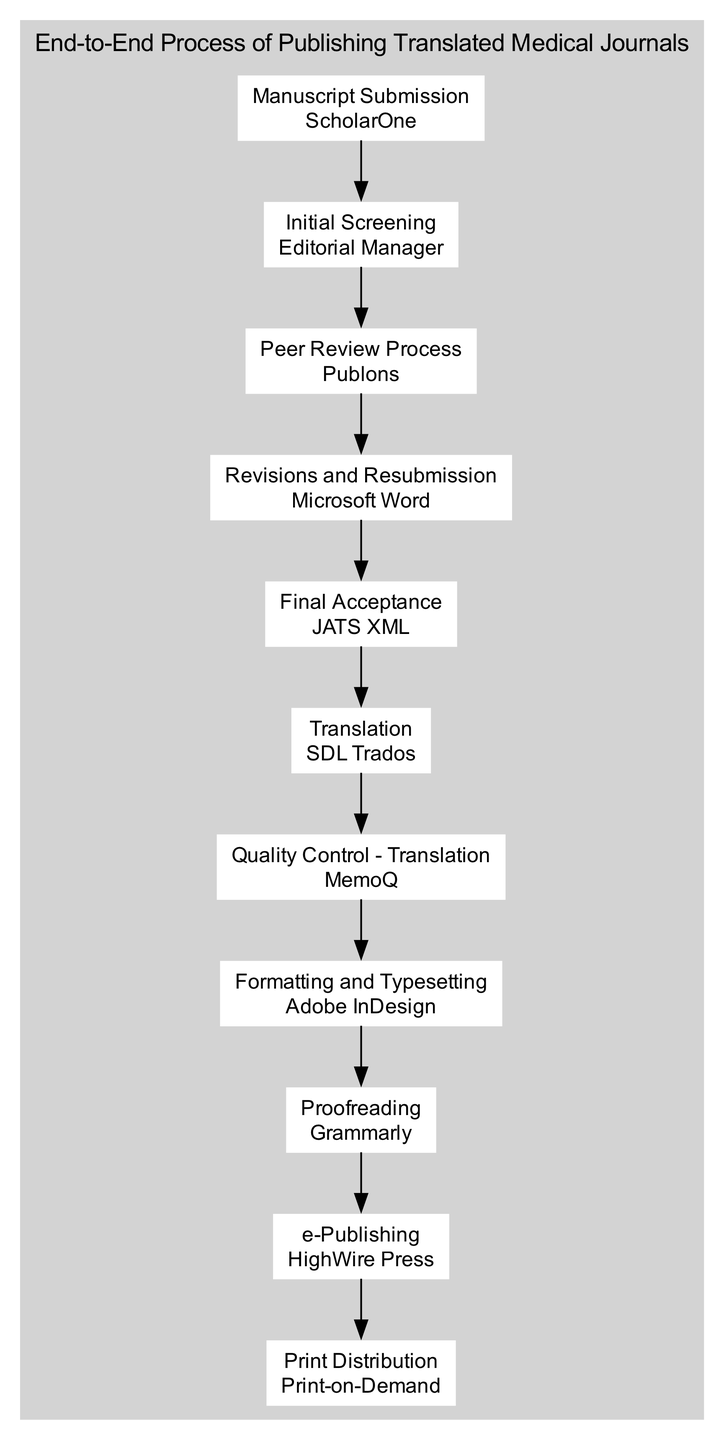What is the first step in the clinical pathway? The diagram shows that the first step in the clinical pathway is "Manuscript Submission." This is indicated by the placement of "Manuscript Submission" at the beginning of the sequence in the diagram.
Answer: Manuscript Submission How many steps are there in total in the clinical pathway? By counting the individual steps outlined in the diagram, we find a total of 11 distinct steps each connected sequentially from start to finish.
Answer: 11 Which tool is used for translations? According to the diagram, the tool used for translations in the clinical pathway is "SDL Trados," specified in the step labeled "Translation."
Answer: SDL Trados What follows the "Peer Review Process"? The diagram indicates that after the "Peer Review Process," the next step is "Revisions and Resubmission." This is shown by the direct connection from "Peer Review Process" to "Revisions and Resubmission."
Answer: Revisions and Resubmission What is the last step in the clinical pathway? The last step in the clinical pathway is "Print Distribution," which is positioned at the end of the flowchart, signifying it as the final action in the manuscript publishing process.
Answer: Print Distribution What is the tool used during the "Proofreading" step? The diagram specifies that the tool used for the "Proofreading" step is "Grammarly," as shown in the label connected to that step.
Answer: Grammarly How many steps involve a tool related to translation? By reviewing the diagram, the steps "Translation" and "Quality Control - Translation" both involve tools specifically related to translation, leading to a total of 2 such steps.
Answer: 2 Which step directly precedes the final acceptance? The step that directly precedes "Final Acceptance" is "Revisions and Resubmission," which is indicated by the connection flowing into "Final Acceptance" in the diagram.
Answer: Revisions and Resubmission Which tool is used for final publishing of translated documents? The diagram clearly shows that the tool used for final publishing, under the step "e-Publishing," is "HighWire Press." This is indicated by the direct association of the tool with that step.
Answer: HighWire Press Which step uses "Adobe InDesign" as a tool? The tool "Adobe InDesign" is associated with the step "Formatting and Typesetting," which is clearly indicated in the diagram as the step where this tool is applied.
Answer: Formatting and Typesetting 